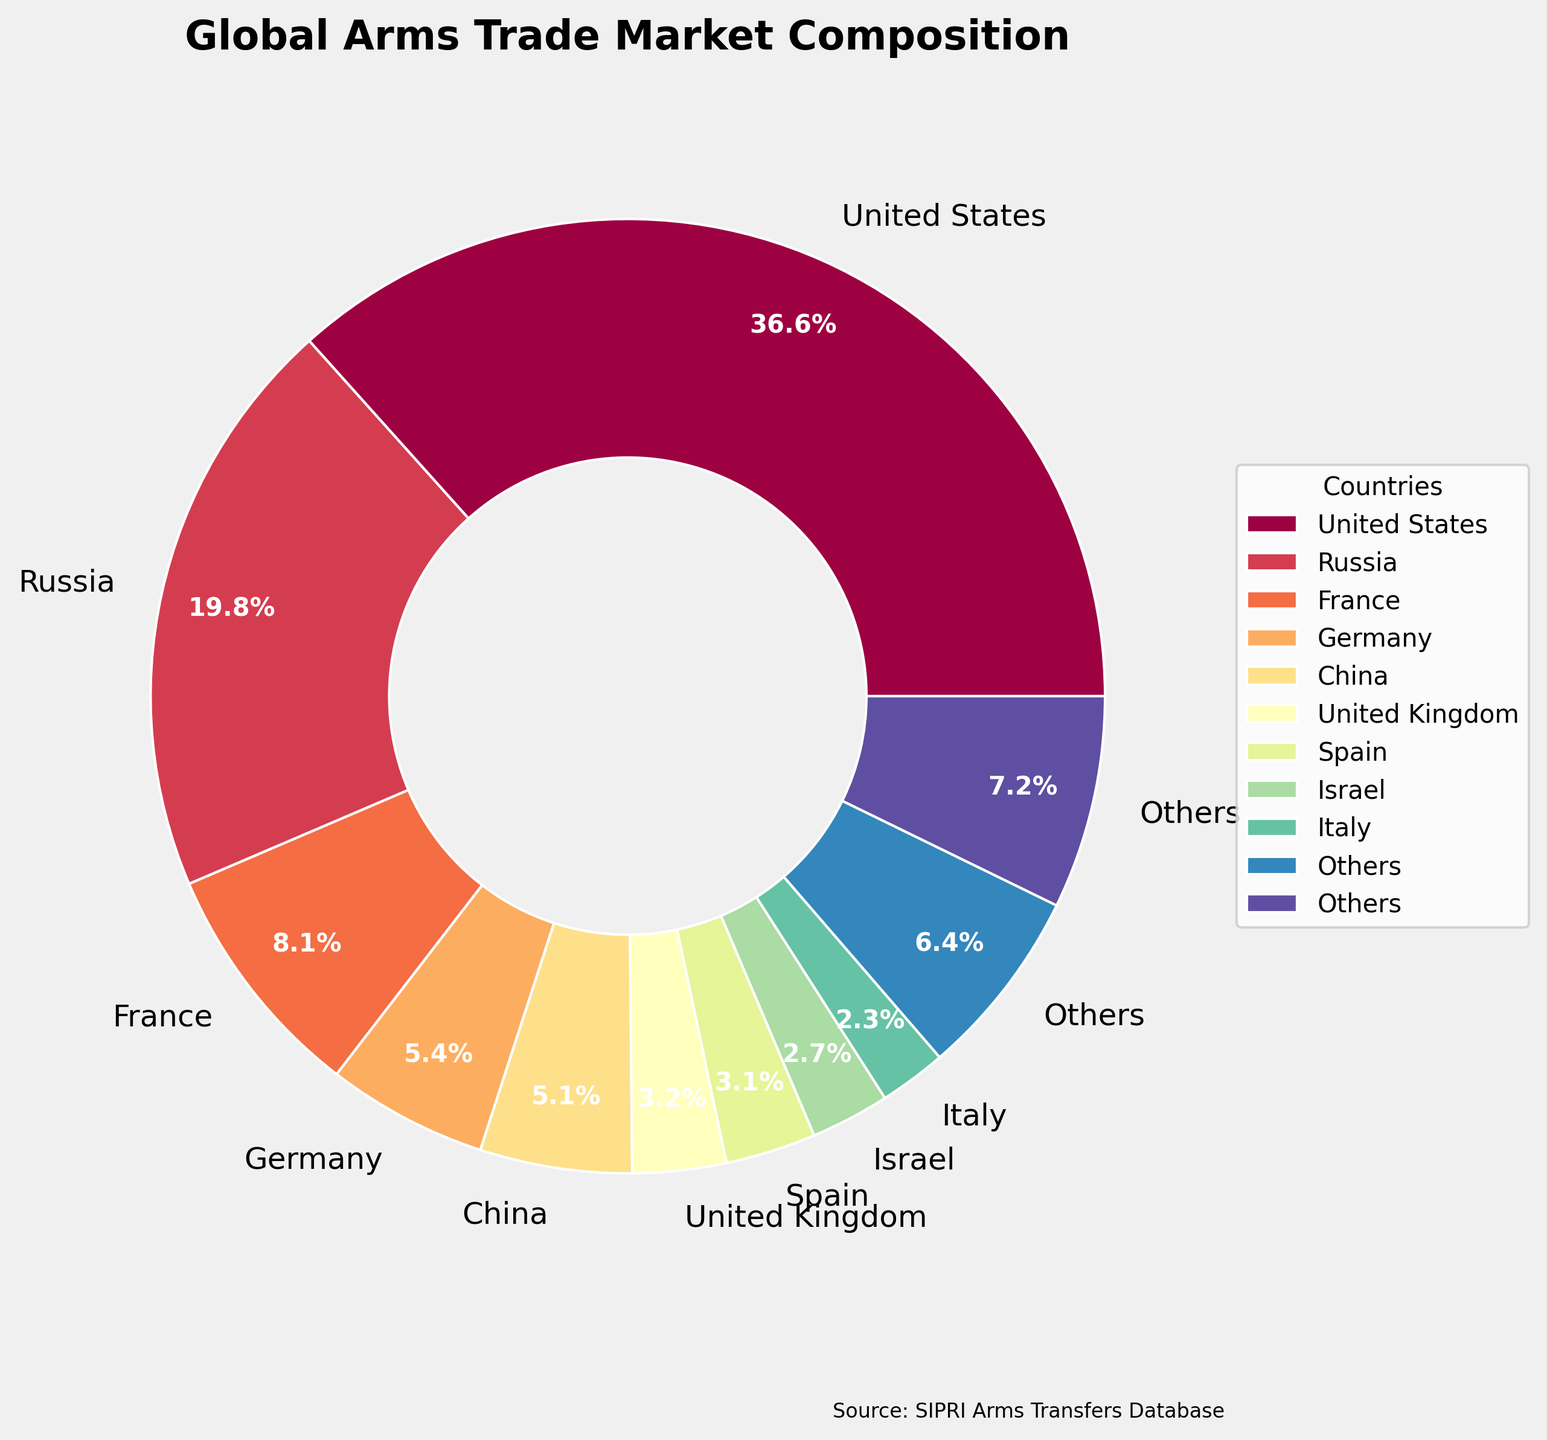What's the combined market share of United States and Russia? The pie chart shows the market shares of individual countries. To find the combined market share of the United States (37%) and Russia (20%), add these percentages together: 37% + 20% = 57%.
Answer: 57% Which country has a smaller market share, Italy or Netherlands? By observing the pie chart, we can see that Italy has a market share of 2.3%, while the Netherlands has a market share of 1.9%. Since 1.9% is smaller, the Netherlands has a smaller market share.
Answer: Netherlands What is the difference in market share between France and the United Kingdom? Looking at the chart, France has a market share of 8.2% and the United Kingdom has 3.2%. Subtract the market share of the United Kingdom from that of France to find the difference: 8.2% - 3.2% = 5%.
Answer: 5% Which countries have a market share greater than 5%? The countries with a market share greater than 5% as shown in the pie chart are United States (37%), Russia (20%), France (8.2%), Germany (5.5%), and China (5.2%).
Answer: United States, Russia, France, Germany, China How many countries have a market share less than 2%? By examining the pie chart, the countries with a market share less than 2% are Netherlands (1.9%), South Korea (1.7%), Sweden (1.3%), Turkey (0.9%), Canada (0.8%), Australia (0.7%). Counting these gives 6 countries.
Answer: 6 What is the market share percentage of countries classified under "Others"? The category "Others" represents countries with smaller individual market shares. According to the pie chart, "Others" account for 6.5%.
Answer: 6.5% Is Spain's market share higher or lower than Israel's? The pie chart shows that Spain has a market share of 3.1%, while Israel has 2.7%. Since 3.1% is greater than 2.7%, Spain's market share is higher.
Answer: Higher By how much does the market share of Germany exceed that of China? From the chart, Germany has a market share of 5.5% while China has 5.2%. Subtract China's share from Germany's to find the difference: 5.5% - 5.2% = 0.3%.
Answer: 0.3% What proportion of the total market share is represented by countries with less than 2% market share each? Summing up the market shares of the Netherlands (1.9%), South Korea (1.7%), Sweden (1.3%), Turkey (0.9%), Canada (0.8%), and Australia (0.7%), we get 7.3%. Therefore, these countries represent 7.3% of the total market share.
Answer: 7.3% How does the market share of the United Kingdom compare to that of Spain? According to the pie chart, the United Kingdom has a market share of 3.2%, while Spain has 3.1%. Since 3.2% is slightly greater than 3.1%, the United Kingdom's market share is higher by 0.1%.
Answer: United Kingdom by 0.1% 